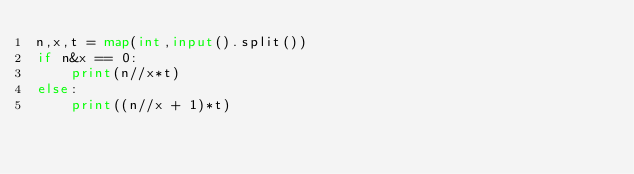Convert code to text. <code><loc_0><loc_0><loc_500><loc_500><_Python_>n,x,t = map(int,input().split())
if n&x == 0:
    print(n//x*t)
else:
    print((n//x + 1)*t)</code> 